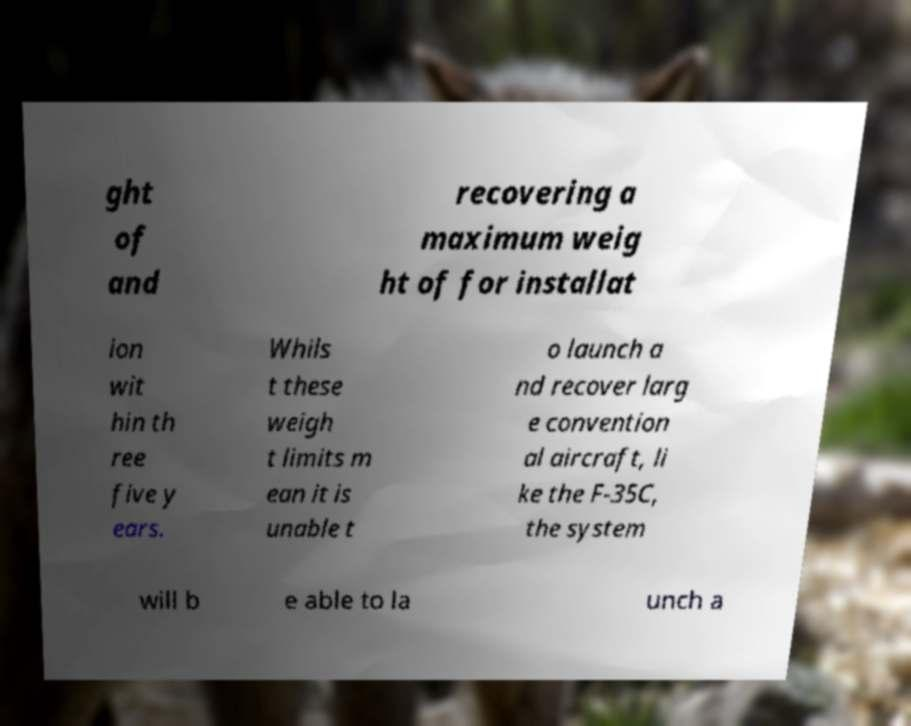Please identify and transcribe the text found in this image. ght of and recovering a maximum weig ht of for installat ion wit hin th ree five y ears. Whils t these weigh t limits m ean it is unable t o launch a nd recover larg e convention al aircraft, li ke the F-35C, the system will b e able to la unch a 